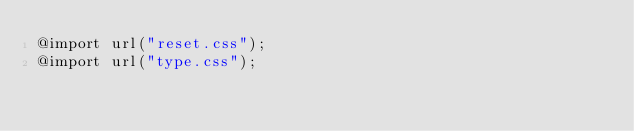Convert code to text. <code><loc_0><loc_0><loc_500><loc_500><_CSS_>@import url("reset.css"); 
@import url("type.css");</code> 